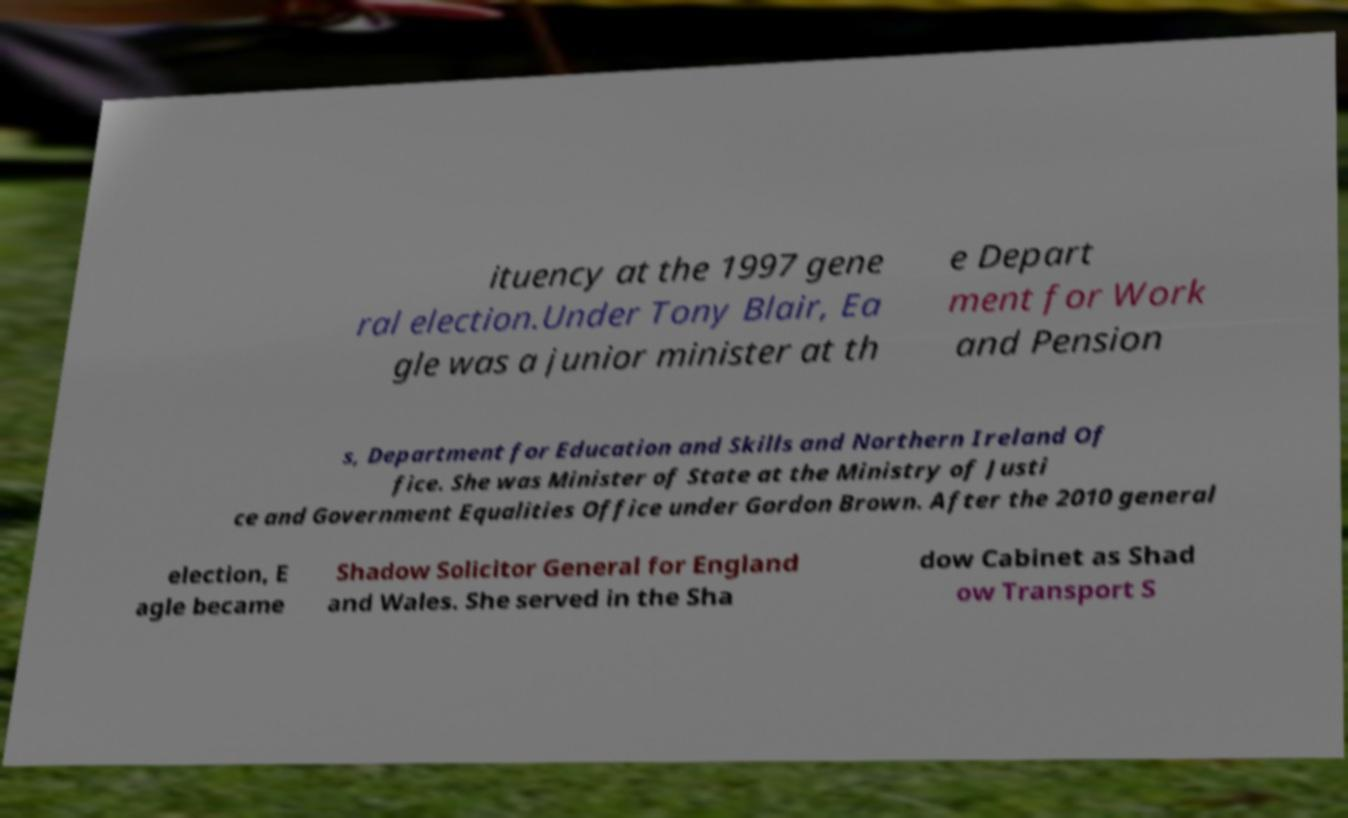Can you read and provide the text displayed in the image?This photo seems to have some interesting text. Can you extract and type it out for me? ituency at the 1997 gene ral election.Under Tony Blair, Ea gle was a junior minister at th e Depart ment for Work and Pension s, Department for Education and Skills and Northern Ireland Of fice. She was Minister of State at the Ministry of Justi ce and Government Equalities Office under Gordon Brown. After the 2010 general election, E agle became Shadow Solicitor General for England and Wales. She served in the Sha dow Cabinet as Shad ow Transport S 